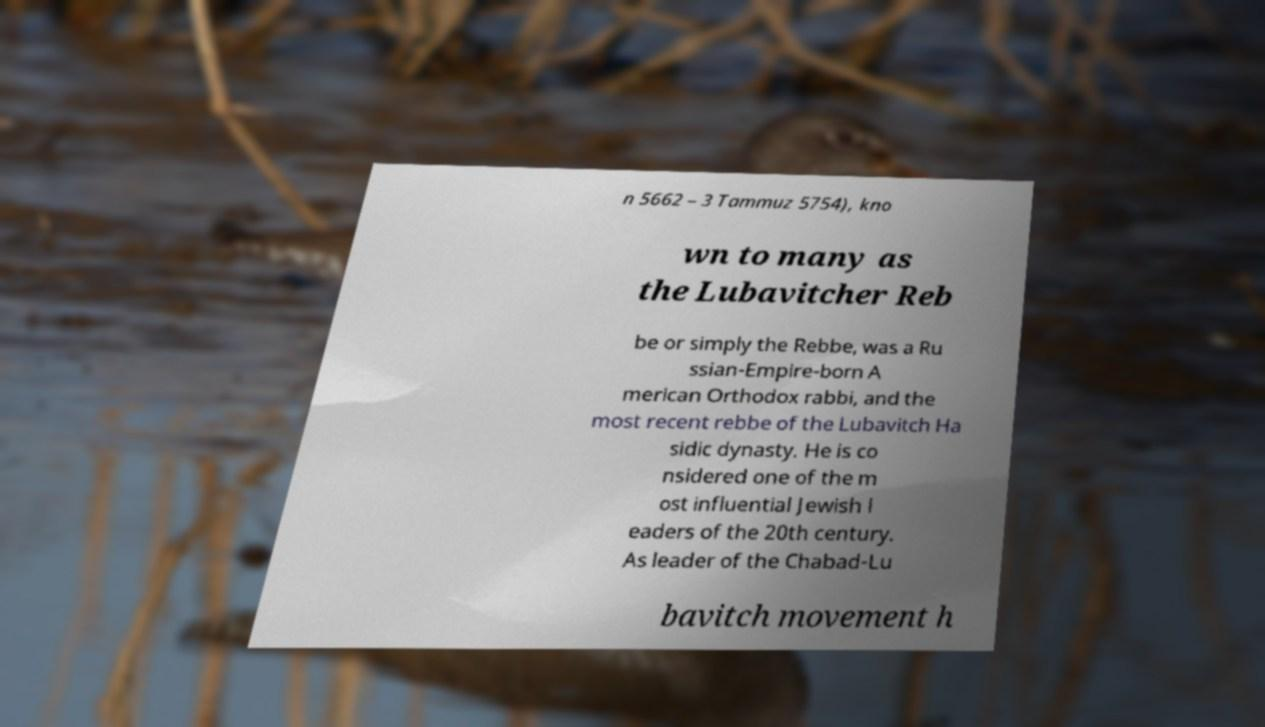Could you assist in decoding the text presented in this image and type it out clearly? n 5662 – 3 Tammuz 5754), kno wn to many as the Lubavitcher Reb be or simply the Rebbe, was a Ru ssian-Empire-born A merican Orthodox rabbi, and the most recent rebbe of the Lubavitch Ha sidic dynasty. He is co nsidered one of the m ost influential Jewish l eaders of the 20th century. As leader of the Chabad-Lu bavitch movement h 